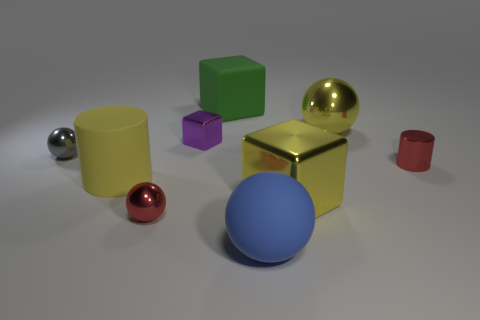Are there any yellow rubber objects that have the same shape as the green rubber thing? Upon reviewing the image, I can confirm that there are no yellow objects made of rubber that share the same shape as the green cube visible in the scene. 